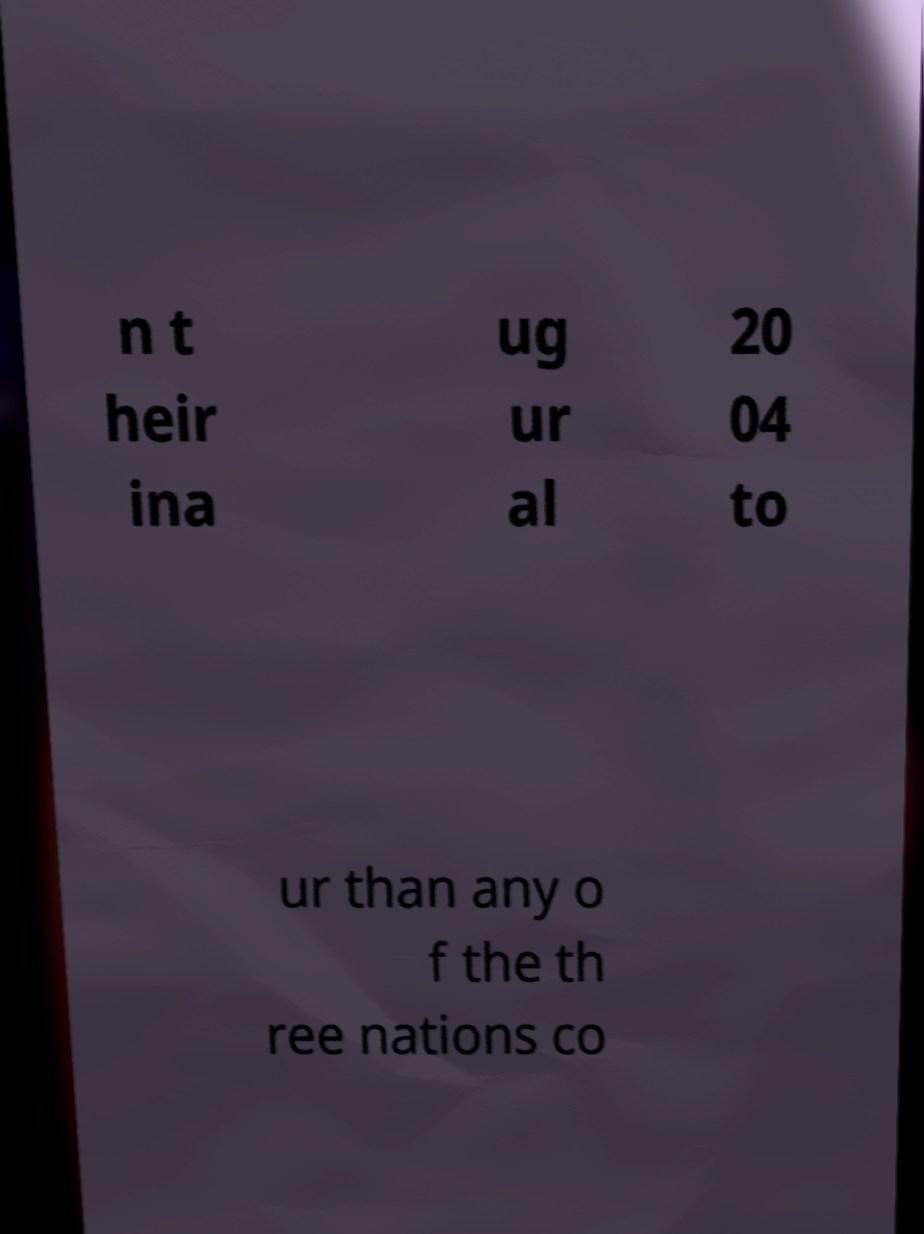There's text embedded in this image that I need extracted. Can you transcribe it verbatim? n t heir ina ug ur al 20 04 to ur than any o f the th ree nations co 